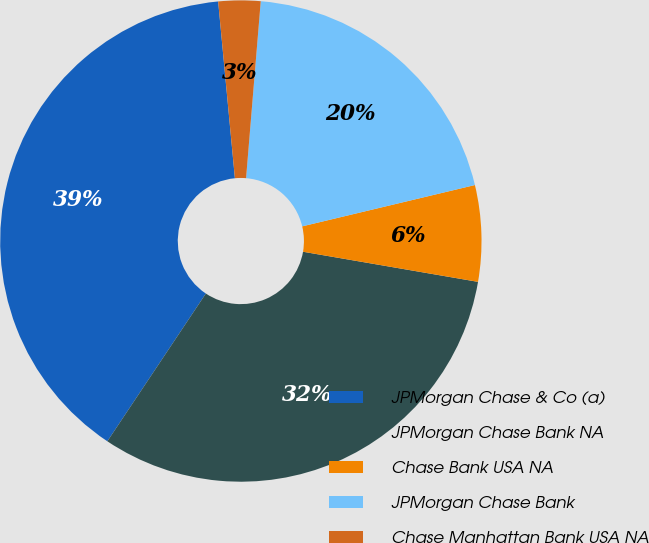Convert chart to OTSL. <chart><loc_0><loc_0><loc_500><loc_500><pie_chart><fcel>JPMorgan Chase & Co (a)<fcel>JPMorgan Chase Bank NA<fcel>Chase Bank USA NA<fcel>JPMorgan Chase Bank<fcel>Chase Manhattan Bank USA NA<nl><fcel>39.13%<fcel>31.64%<fcel>6.45%<fcel>19.94%<fcel>2.82%<nl></chart> 